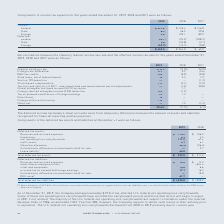According to Roper Technologies's financial document, How do the deferred income tax balance sheet accounts arise from? Based on the financial document, the answer is temporary differences between the amount of assets and liabilities recognized for financial reporting and tax purposes. Also, What are the components of deferred tax assets? The document contains multiple relevant values: Reserves and accrued expenses, Inventories, Net operating loss carryforwards, R&D credits, Valuation allowance, Outside basis difference on investments held for sale, Lease liability. From the document: "Net operating loss carryforwards 111.2 67.9 Reserves and accrued expenses $ 175.2 $ 156.5 Valuation allowance (36.3) (26.4) Lease liability 1 64.0 — I..." Also, What was the total deferred tax liabilities in 2018? According to the financial document, $ 1,090.2. The relevant text states: "Total deferred tax liabilities $ 1,335.0 $ 1,090.2..." Also, can you calculate: What is the percentage change in total deferred tax assets from 2018 to 2019? To answer this question, I need to perform calculations using the financial data. The calculation is: (322.5-211.3)/211.3 , which equals 52.63 (percentage). This is based on the information: "Total deferred tax assets $ 322.5 $ 211.3 Total deferred tax assets $ 322.5 $ 211.3..." The key data points involved are: 211.3, 322.5. Also, can you calculate: What is the proportion of deferred tax liabilities of amortizable intangible assets as well as the accrued tax on unremitted foreign earnings over total deferred tax liabilities in 2019? To answer this question, I need to perform calculations using the financial data. The calculation is: (1,229.9+17.1)/1,335.0 , which equals 0.93. This is based on the information: "Amortizable intangible assets 1,229.9 1,043.0 Accrued tax on unremitted foreign earnings 17.1 16.3 Total deferred tax liabilities $ 1,335.0 $ 1,090.2..." The key data points involved are: 1,229.9, 1,335.0, 17.1. Also, can you calculate: What is the ratio of inventories from 2018 to 2019? Based on the calculation: 4.5/4.3 , the result is 1.05. This is based on the information: "Inventories 4.3 4.5 Inventories 4.3 4.5..." The key data points involved are: 4.3, 4.5. 